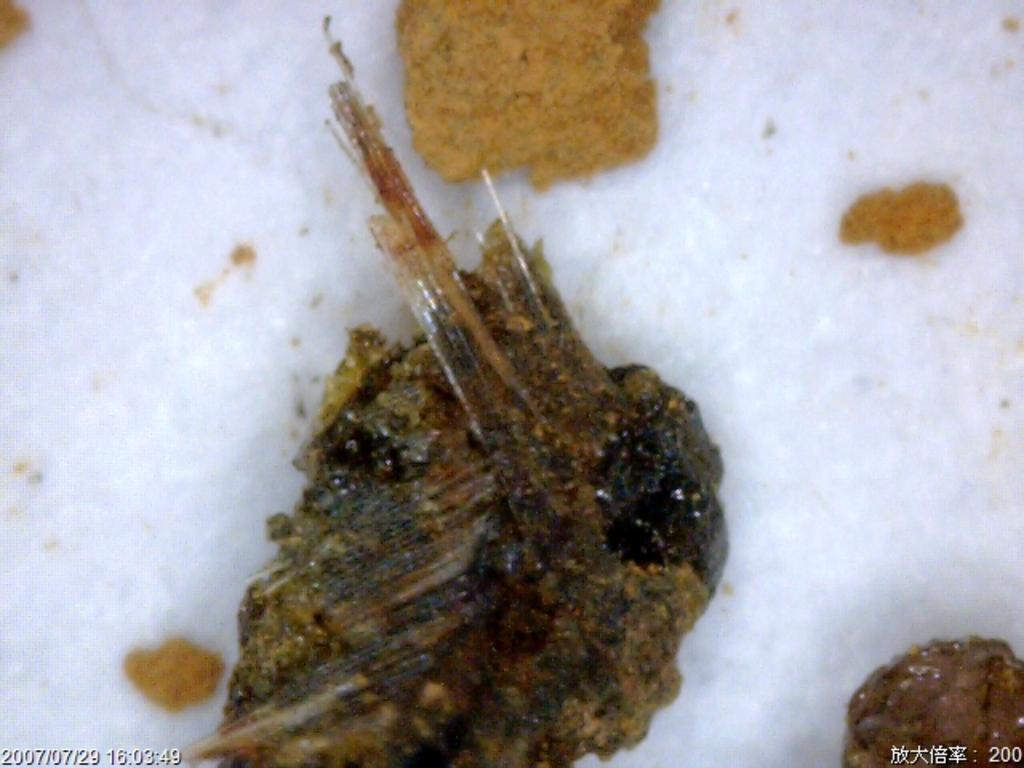What is the color of the object on which other objects are placed? The color of the object on which other objects are placed is white. What can be found at the bottom of the image? There is text visible at the bottom of the image. How does the wind affect the objects placed on the white object in the image? There is no wind present in the image, so its effect on the objects cannot be determined. 